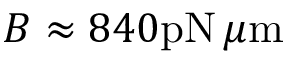<formula> <loc_0><loc_0><loc_500><loc_500>B \approx 8 4 0 p N \, \mu m</formula> 